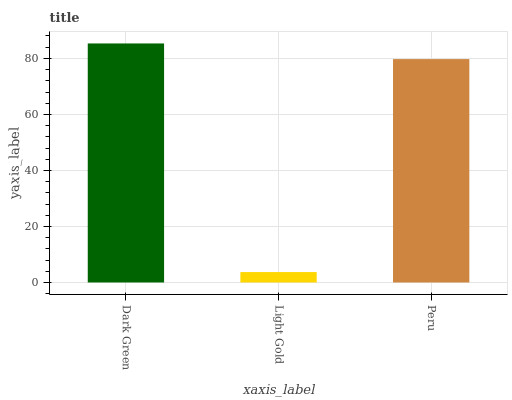Is Light Gold the minimum?
Answer yes or no. Yes. Is Dark Green the maximum?
Answer yes or no. Yes. Is Peru the minimum?
Answer yes or no. No. Is Peru the maximum?
Answer yes or no. No. Is Peru greater than Light Gold?
Answer yes or no. Yes. Is Light Gold less than Peru?
Answer yes or no. Yes. Is Light Gold greater than Peru?
Answer yes or no. No. Is Peru less than Light Gold?
Answer yes or no. No. Is Peru the high median?
Answer yes or no. Yes. Is Peru the low median?
Answer yes or no. Yes. Is Dark Green the high median?
Answer yes or no. No. Is Dark Green the low median?
Answer yes or no. No. 